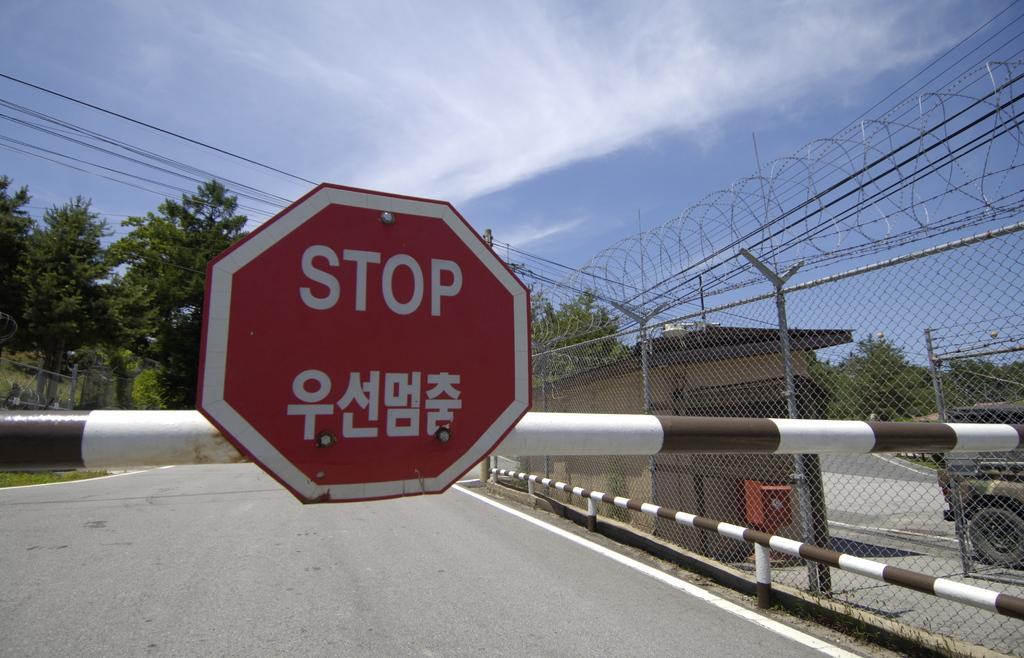Describe this image in one or two sentences. In this picture we can see a signboard, trees, fence and a vehicle on the road and in the background we can see the sky with clouds. 